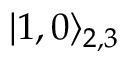Convert formula to latex. <formula><loc_0><loc_0><loc_500><loc_500>| 1 , 0 \rangle _ { 2 , 3 }</formula> 